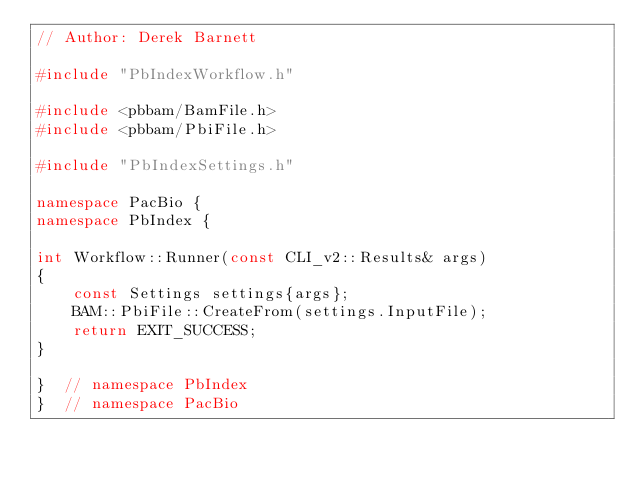Convert code to text. <code><loc_0><loc_0><loc_500><loc_500><_C++_>// Author: Derek Barnett

#include "PbIndexWorkflow.h"

#include <pbbam/BamFile.h>
#include <pbbam/PbiFile.h>

#include "PbIndexSettings.h"

namespace PacBio {
namespace PbIndex {

int Workflow::Runner(const CLI_v2::Results& args)
{
    const Settings settings{args};
    BAM::PbiFile::CreateFrom(settings.InputFile);
    return EXIT_SUCCESS;
}

}  // namespace PbIndex
}  // namespace PacBio
</code> 